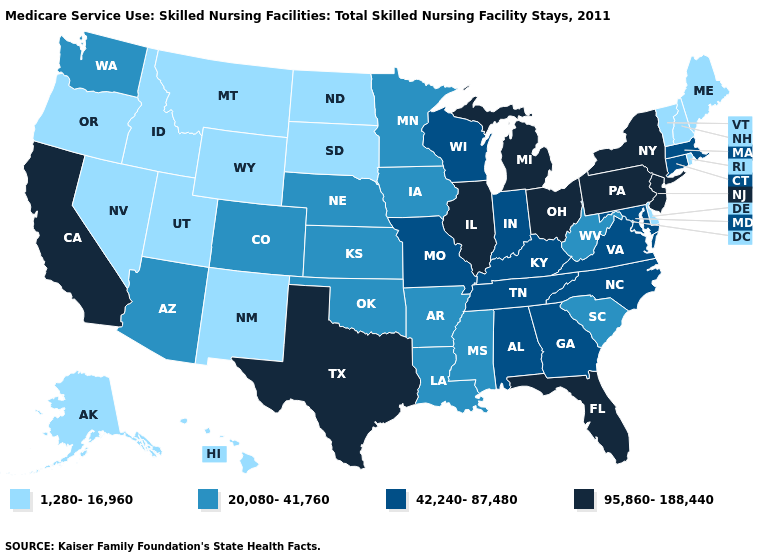What is the highest value in the Northeast ?
Write a very short answer. 95,860-188,440. Name the states that have a value in the range 95,860-188,440?
Give a very brief answer. California, Florida, Illinois, Michigan, New Jersey, New York, Ohio, Pennsylvania, Texas. Which states hav the highest value in the MidWest?
Keep it brief. Illinois, Michigan, Ohio. Among the states that border Maine , which have the lowest value?
Write a very short answer. New Hampshire. Does California have the lowest value in the USA?
Answer briefly. No. Does California have the highest value in the USA?
Keep it brief. Yes. Does New Mexico have the lowest value in the West?
Concise answer only. Yes. Name the states that have a value in the range 1,280-16,960?
Keep it brief. Alaska, Delaware, Hawaii, Idaho, Maine, Montana, Nevada, New Hampshire, New Mexico, North Dakota, Oregon, Rhode Island, South Dakota, Utah, Vermont, Wyoming. Does the map have missing data?
Quick response, please. No. Does Arkansas have the lowest value in the USA?
Keep it brief. No. Which states have the lowest value in the USA?
Keep it brief. Alaska, Delaware, Hawaii, Idaho, Maine, Montana, Nevada, New Hampshire, New Mexico, North Dakota, Oregon, Rhode Island, South Dakota, Utah, Vermont, Wyoming. Name the states that have a value in the range 95,860-188,440?
Write a very short answer. California, Florida, Illinois, Michigan, New Jersey, New York, Ohio, Pennsylvania, Texas. Which states hav the highest value in the MidWest?
Quick response, please. Illinois, Michigan, Ohio. Among the states that border Michigan , does Indiana have the highest value?
Give a very brief answer. No. What is the value of New Hampshire?
Give a very brief answer. 1,280-16,960. 